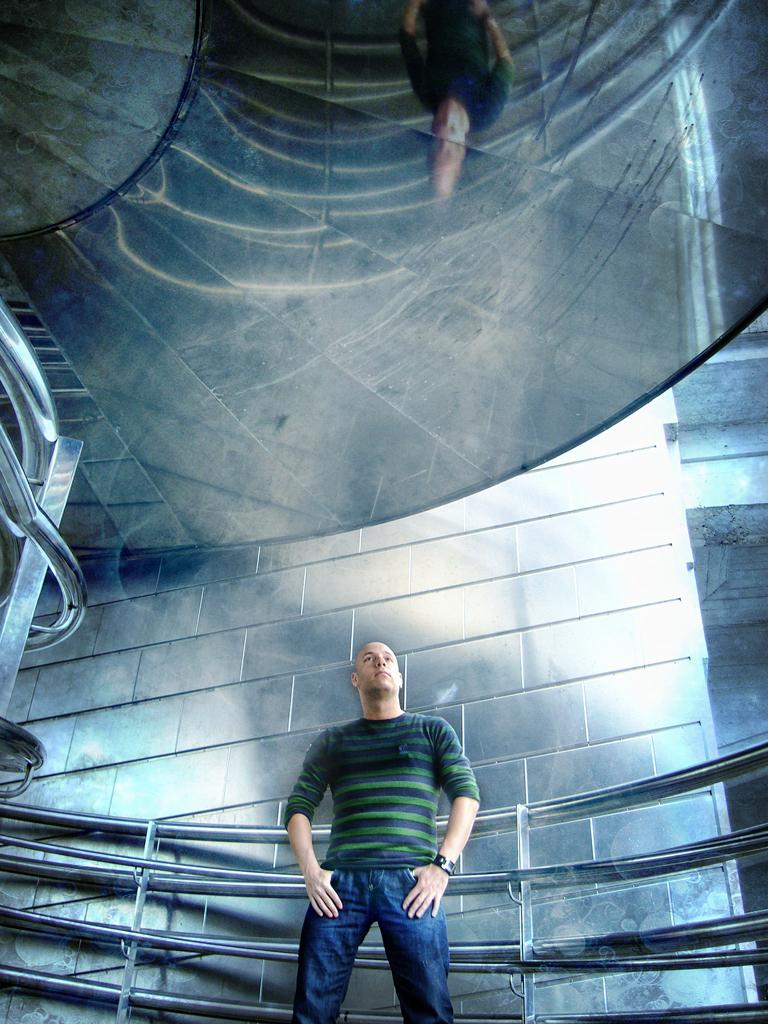What is the main subject of the image? There is a person standing in the image. What is the person wearing? The person is wearing a green t-shirt and blue pants. What is behind the person in the image? There is a wall behind the person. What else can be seen in the image? There are grills visible in the image. What type of haircut does the giraffe have in the image? There is no giraffe present in the image, so it is not possible to answer that question. 